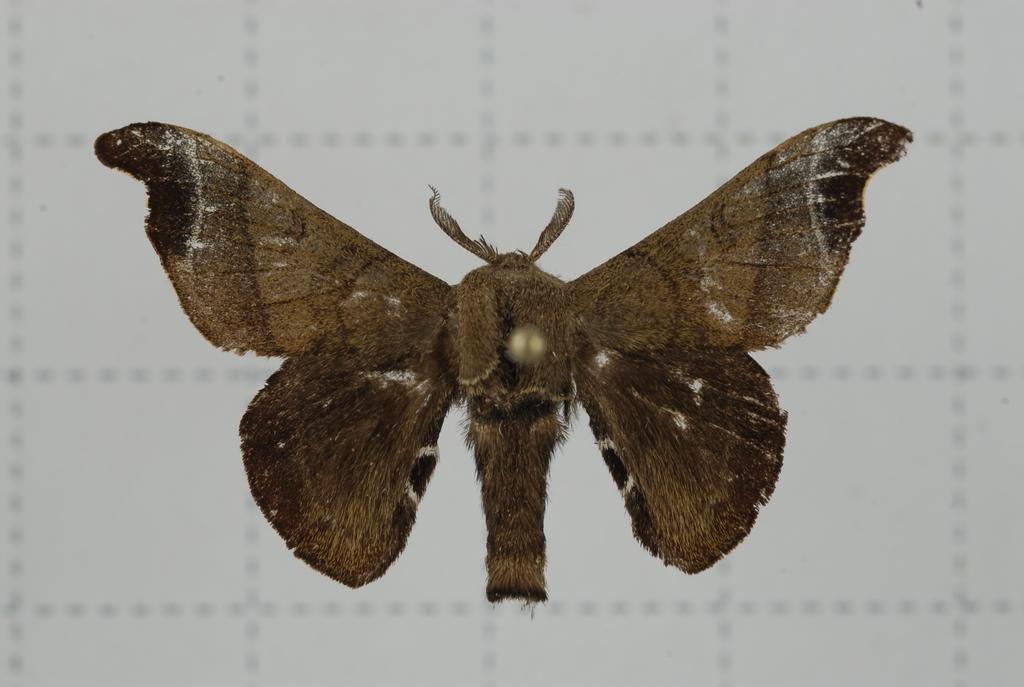Can you describe this image briefly? In this image we can see a butterfly which is brown in color flying in air. 